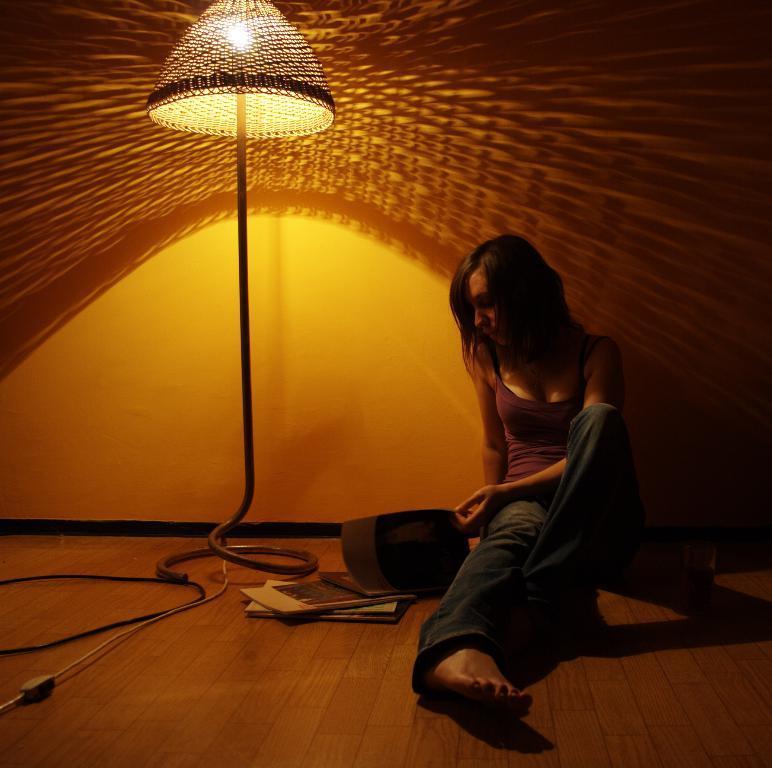How would you summarize this image in a sentence or two? In this image we can see woman sitting on the floor at the light. On the floor we can see wires and books. In the background there is a wall. 